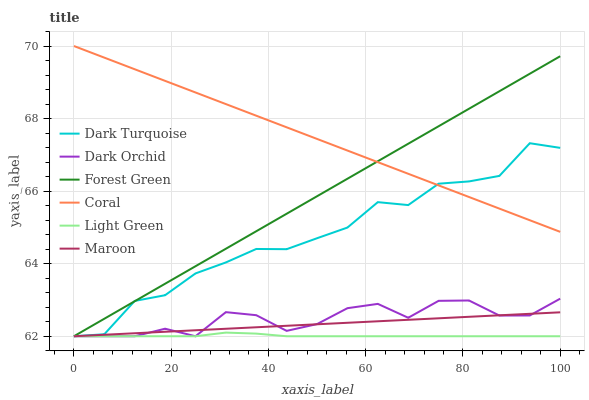Does Maroon have the minimum area under the curve?
Answer yes or no. No. Does Maroon have the maximum area under the curve?
Answer yes or no. No. Is Coral the smoothest?
Answer yes or no. No. Is Coral the roughest?
Answer yes or no. No. Does Coral have the lowest value?
Answer yes or no. No. Does Maroon have the highest value?
Answer yes or no. No. Is Dark Orchid less than Coral?
Answer yes or no. Yes. Is Coral greater than Light Green?
Answer yes or no. Yes. Does Dark Orchid intersect Coral?
Answer yes or no. No. 